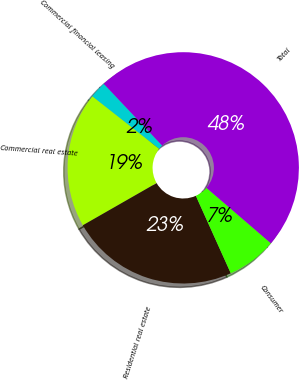<chart> <loc_0><loc_0><loc_500><loc_500><pie_chart><fcel>Commercial financial leasing<fcel>Commercial real estate<fcel>Residential real estate<fcel>Consumer<fcel>Total<nl><fcel>2.35%<fcel>18.87%<fcel>23.47%<fcel>6.95%<fcel>48.35%<nl></chart> 